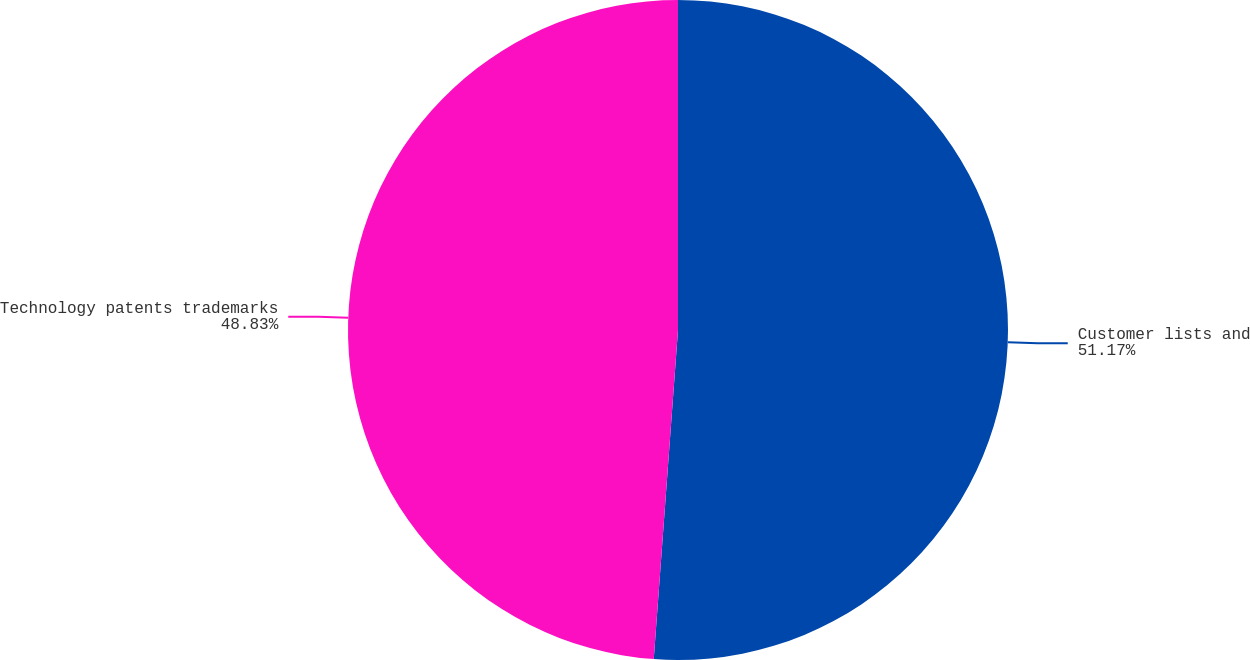Convert chart. <chart><loc_0><loc_0><loc_500><loc_500><pie_chart><fcel>Customer lists and<fcel>Technology patents trademarks<nl><fcel>51.17%<fcel>48.83%<nl></chart> 